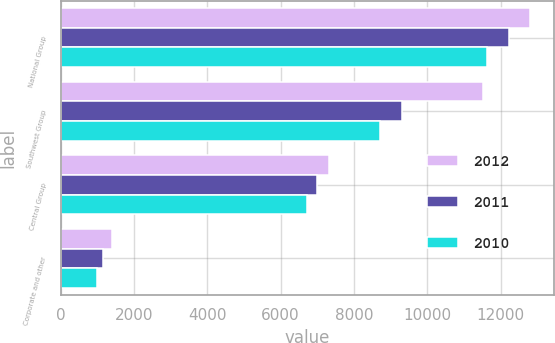Convert chart. <chart><loc_0><loc_0><loc_500><loc_500><stacked_bar_chart><ecel><fcel>National Group<fcel>Southwest Group<fcel>Central Group<fcel>Corporate and other<nl><fcel>2012<fcel>12809<fcel>11506<fcel>7305<fcel>1393<nl><fcel>2011<fcel>12224<fcel>9311<fcel>6982<fcel>1165<nl><fcel>2010<fcel>11624<fcel>8700<fcel>6727<fcel>984<nl></chart> 